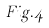Convert formula to latex. <formula><loc_0><loc_0><loc_500><loc_500>F i g . 4</formula> 